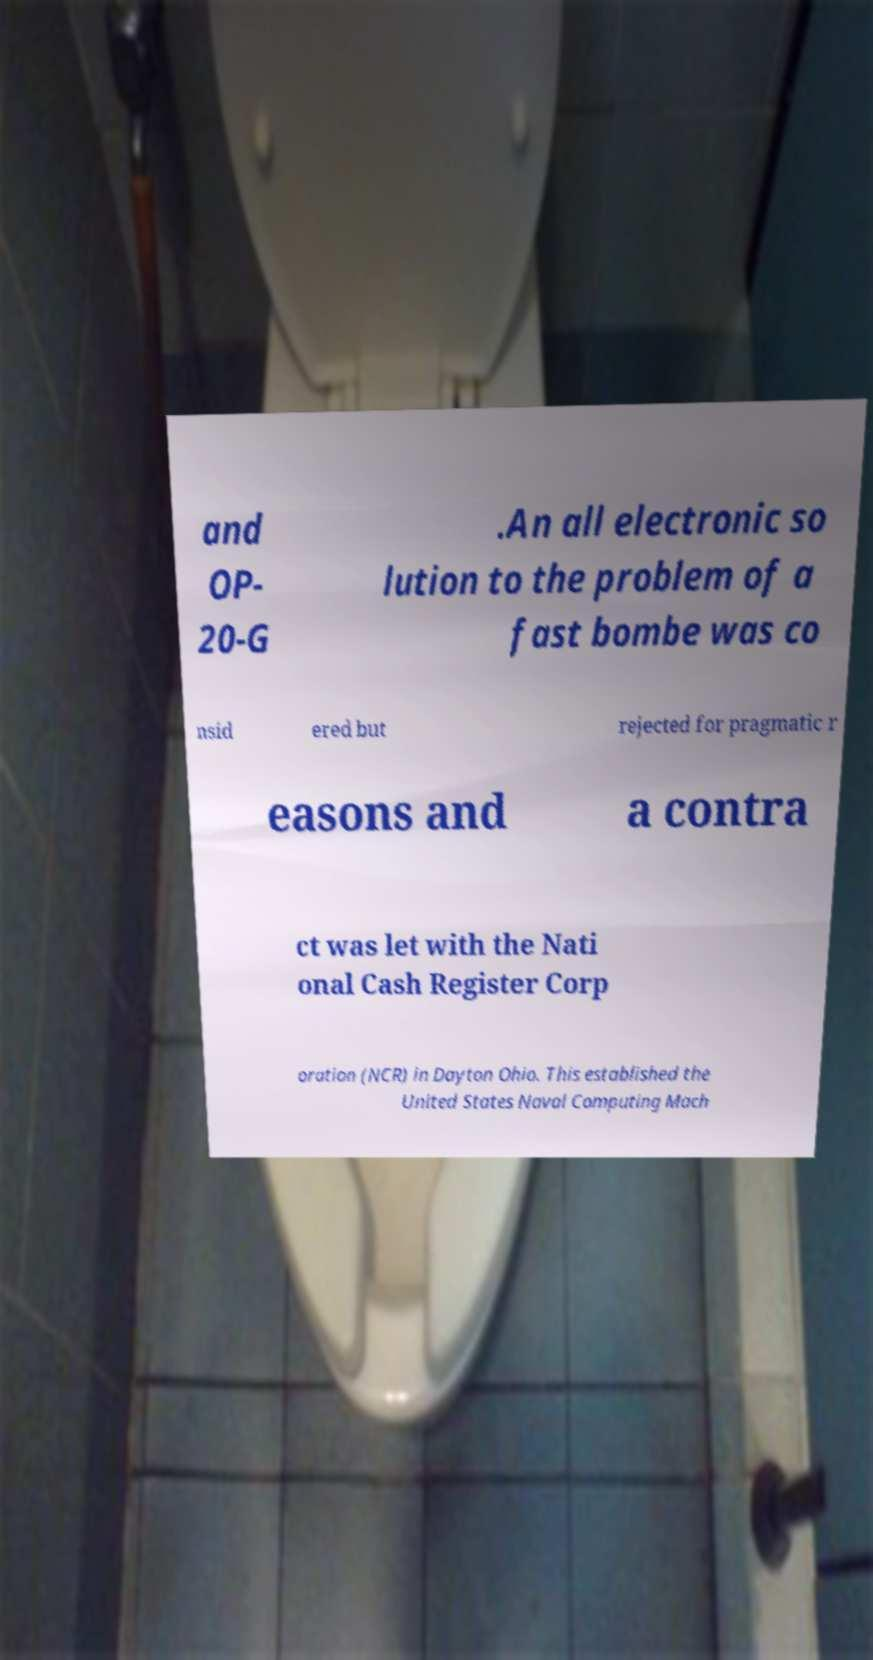What messages or text are displayed in this image? I need them in a readable, typed format. and OP- 20-G .An all electronic so lution to the problem of a fast bombe was co nsid ered but rejected for pragmatic r easons and a contra ct was let with the Nati onal Cash Register Corp oration (NCR) in Dayton Ohio. This established the United States Naval Computing Mach 